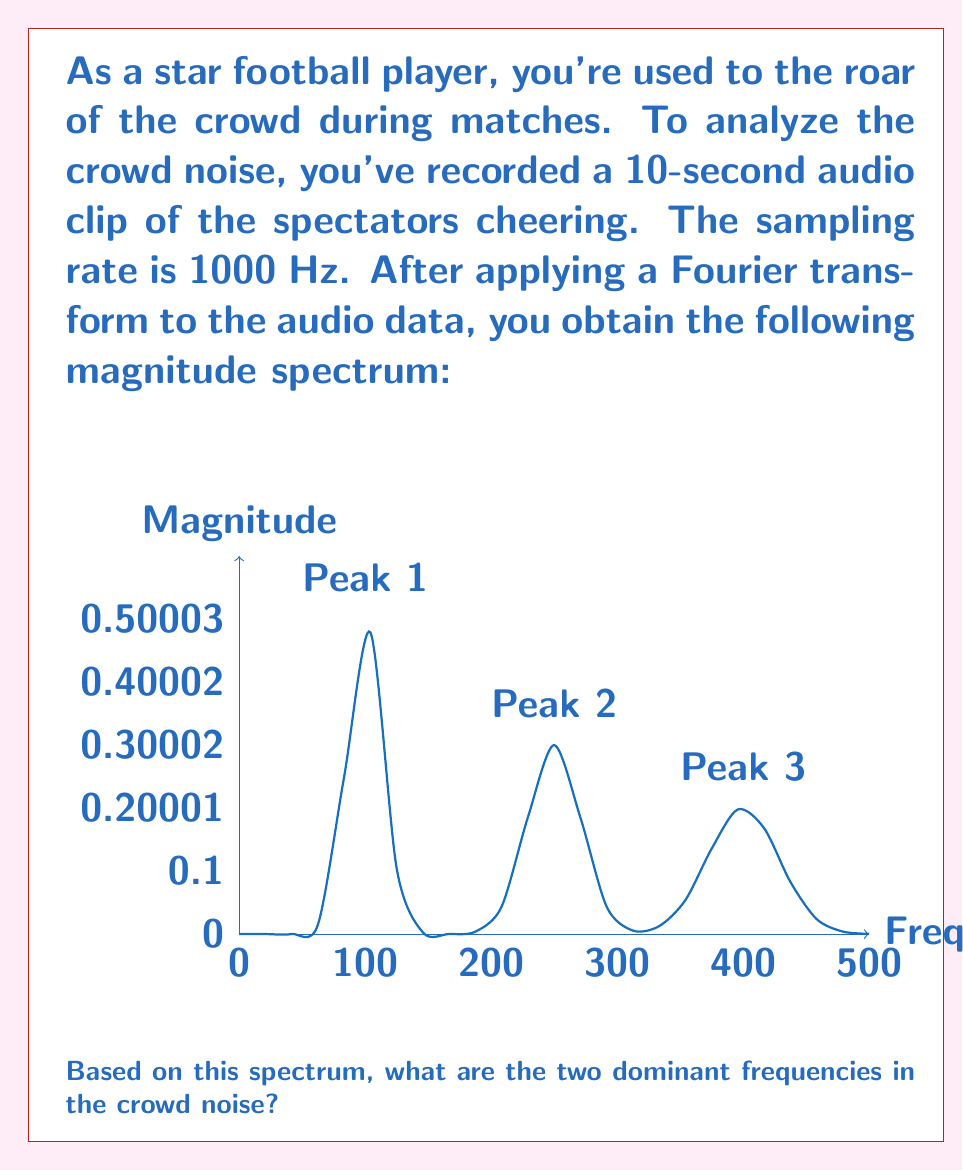Can you answer this question? To determine the dominant frequencies in the crowd noise, we need to analyze the magnitude spectrum obtained from the Fourier transform of the audio data. The process is as follows:

1) The magnitude spectrum shows the strength of different frequency components in the signal.

2) The dominant frequencies are those with the highest magnitudes (peaks) in the spectrum.

3) From the graph, we can identify three main peaks:
   - Peak 1 at approximately 100 Hz
   - Peak 2 at approximately 250 Hz
   - Peak 3 at approximately 400 Hz

4) The heights of these peaks represent their relative magnitudes:
   - Peak 1 has the highest magnitude
   - Peak 2 has the second-highest magnitude
   - Peak 3 has the lowest magnitude of the three

5) Since we're asked for the two dominant frequencies, we select the frequencies corresponding to the two highest peaks.

Therefore, the two dominant frequencies in the crowd noise are approximately 100 Hz and 250 Hz.

It's worth noting that in real-world applications, these frequencies might correspond to different aspects of crowd noise. For example:
- Lower frequencies (around 100 Hz) might represent the overall roar of the crowd
- Mid-range frequencies (around 250 Hz) could correspond to collective chants or cheers

As a football player, understanding these dominant frequencies could help you better interpret the crowd's reactions during a match.
Answer: 100 Hz and 250 Hz 